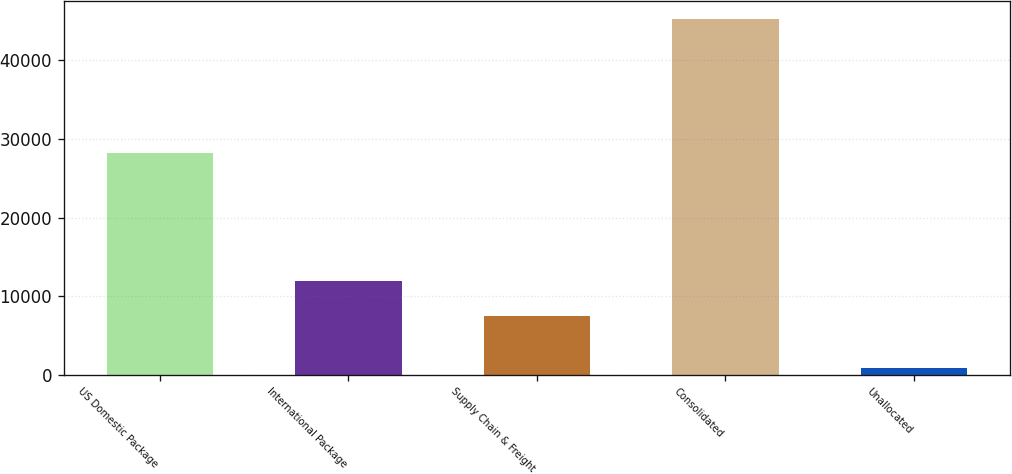Convert chart to OTSL. <chart><loc_0><loc_0><loc_500><loc_500><bar_chart><fcel>US Domestic Package<fcel>International Package<fcel>Supply Chain & Freight<fcel>Consolidated<fcel>Unallocated<nl><fcel>28158<fcel>11888.8<fcel>7440<fcel>45297<fcel>809<nl></chart> 